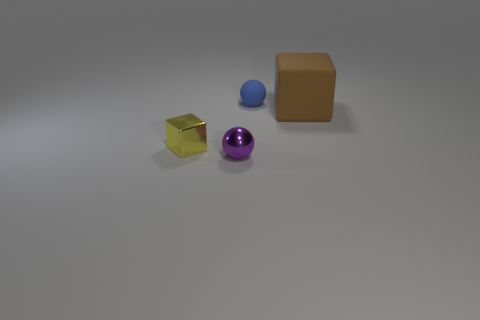Are there any small cubes that are behind the brown rubber thing that is to the right of the tiny object that is in front of the small yellow thing? After closely examining the image, it appears there are no small cubes positioned behind the brown cube-like object. The composition of objects in the image showcases a distinct spatial arrangement with a gold-colored cube located in the foreground to the left, a purple sphere, a blue sphere, and finally, the brown cube-like object in the right corner. There's clear space behind the brown object, with no other items present. 